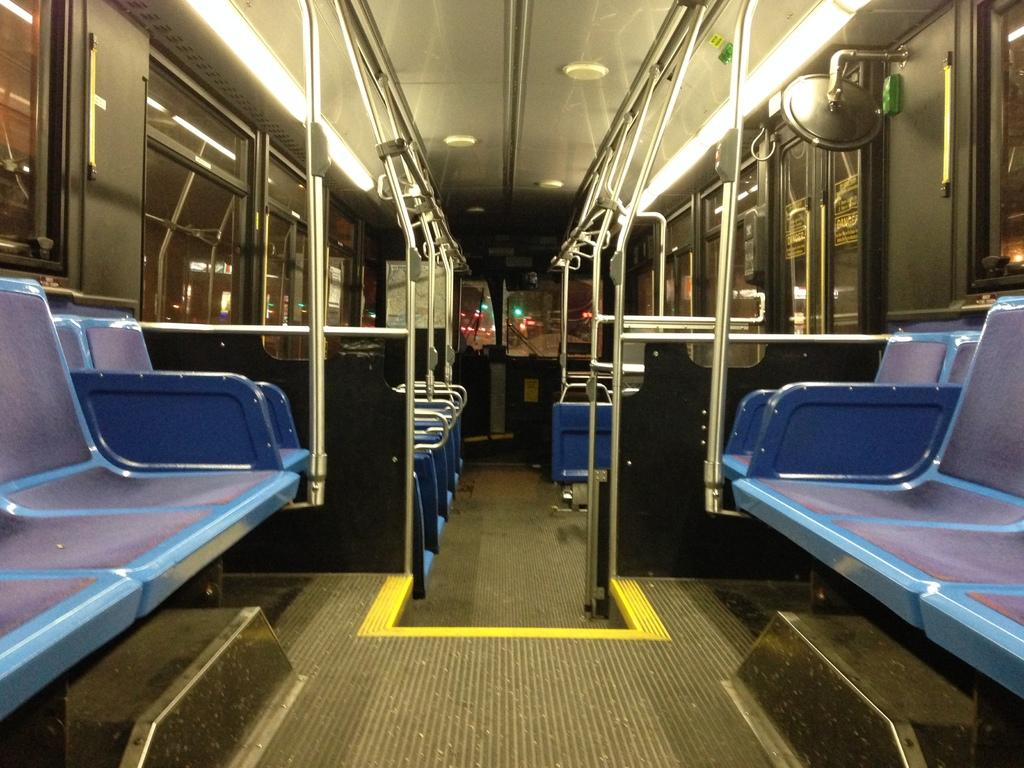What type of space is shown in the image? The image is an inside view of a vehicle. What can be found inside the vehicle? There are seats, lights, poles, and holders inside the vehicle. Can you describe the lighting in the vehicle? There are lights in the vehicle, and additional lights are visible in the background through the glass. What type of lip can be seen on the side of the vehicle in the image? There is no lip visible on the side of the vehicle in the image. What experience can be gained from the image? The image provides a visual representation of the inside of a vehicle, but it does not offer any specific experiences. 